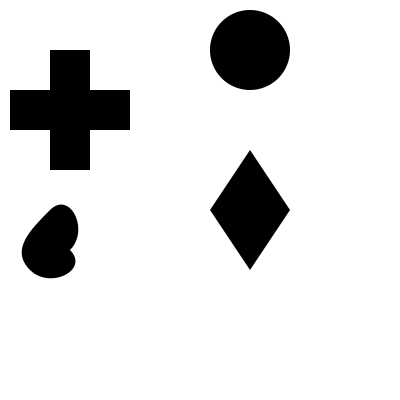Identify the religious symbol that represents Hinduism in the given grid of icons. To identify the religious symbol representing Hinduism, let's analyze each symbol in the grid:

1. Top-left: A cross, which is the primary symbol of Christianity.
2. Top-right: A star and crescent, which is commonly associated with Islam.
3. Bottom-left: The Om symbol, which is a sacred sound and spiritual icon in Indian religions, primarily associated with Hinduism.
4. Bottom-right: The Star of David, which is a widely recognized symbol of Judaism.

The Om symbol, located in the bottom-left corner of the grid, is the correct answer. Here's why:

1. The Om symbol is written in Devanagari script and looks like a stylized "3" with a curl and a dot.
2. It represents the divine in Hinduism, symbolizing the essence of the ultimate reality, consciousness, or Atman.
3. This symbol is often used in Hindu art, temples, and spiritual practices.
4. While it's also used in other Indian religions like Buddhism and Jainism, it is most prominently associated with Hinduism.

Therefore, the Om symbol in the bottom-left corner of the grid is the correct answer for representing Hinduism.
Answer: Om symbol (bottom-left) 